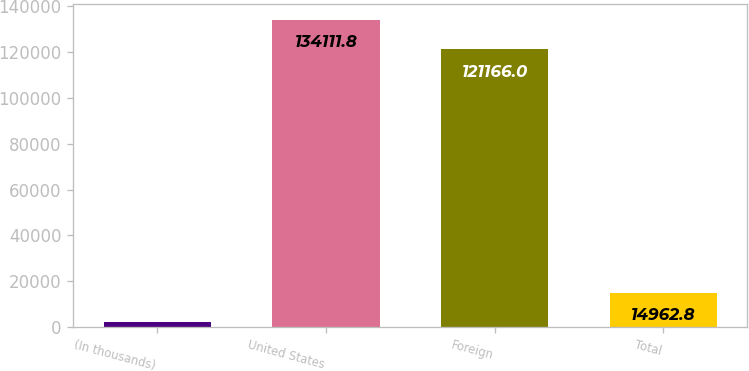Convert chart. <chart><loc_0><loc_0><loc_500><loc_500><bar_chart><fcel>(In thousands)<fcel>United States<fcel>Foreign<fcel>Total<nl><fcel>2017<fcel>134112<fcel>121166<fcel>14962.8<nl></chart> 